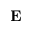Convert formula to latex. <formula><loc_0><loc_0><loc_500><loc_500>E</formula> 